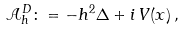Convert formula to latex. <formula><loc_0><loc_0><loc_500><loc_500>\mathcal { A } _ { h } ^ { D } \colon = - h ^ { 2 } \Delta + i \, V ( x ) \, ,</formula> 